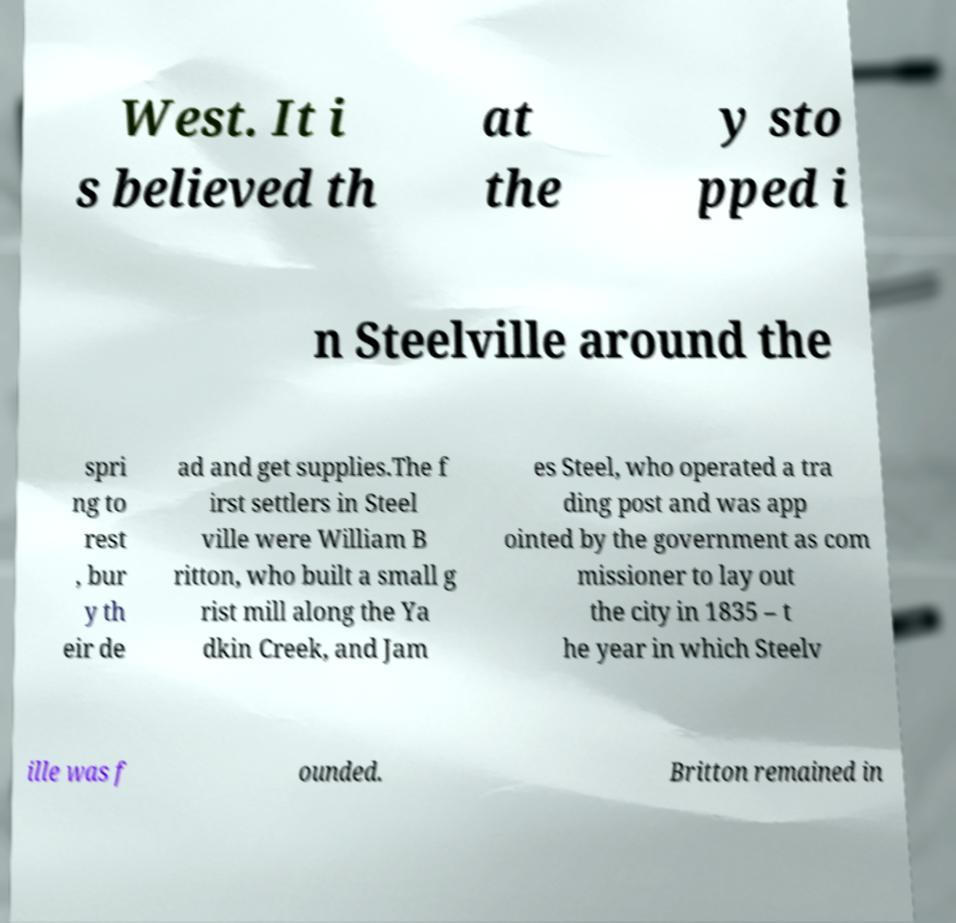I need the written content from this picture converted into text. Can you do that? West. It i s believed th at the y sto pped i n Steelville around the spri ng to rest , bur y th eir de ad and get supplies.The f irst settlers in Steel ville were William B ritton, who built a small g rist mill along the Ya dkin Creek, and Jam es Steel, who operated a tra ding post and was app ointed by the government as com missioner to lay out the city in 1835 – t he year in which Steelv ille was f ounded. Britton remained in 